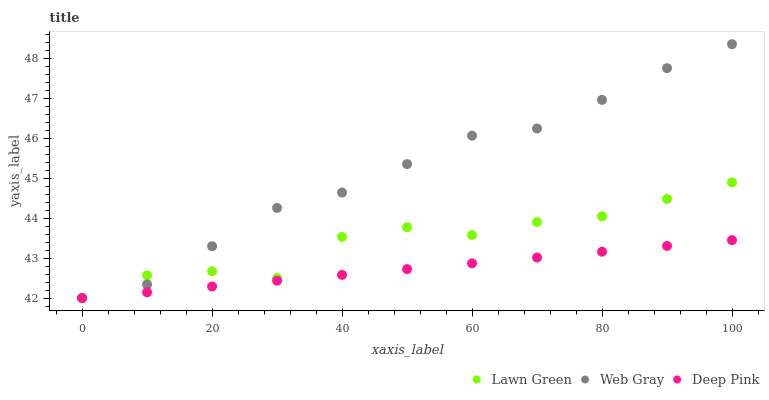Does Deep Pink have the minimum area under the curve?
Answer yes or no. Yes. Does Web Gray have the maximum area under the curve?
Answer yes or no. Yes. Does Web Gray have the minimum area under the curve?
Answer yes or no. No. Does Deep Pink have the maximum area under the curve?
Answer yes or no. No. Is Deep Pink the smoothest?
Answer yes or no. Yes. Is Lawn Green the roughest?
Answer yes or no. Yes. Is Web Gray the smoothest?
Answer yes or no. No. Is Web Gray the roughest?
Answer yes or no. No. Does Lawn Green have the lowest value?
Answer yes or no. Yes. Does Web Gray have the highest value?
Answer yes or no. Yes. Does Deep Pink have the highest value?
Answer yes or no. No. Does Deep Pink intersect Lawn Green?
Answer yes or no. Yes. Is Deep Pink less than Lawn Green?
Answer yes or no. No. Is Deep Pink greater than Lawn Green?
Answer yes or no. No. 